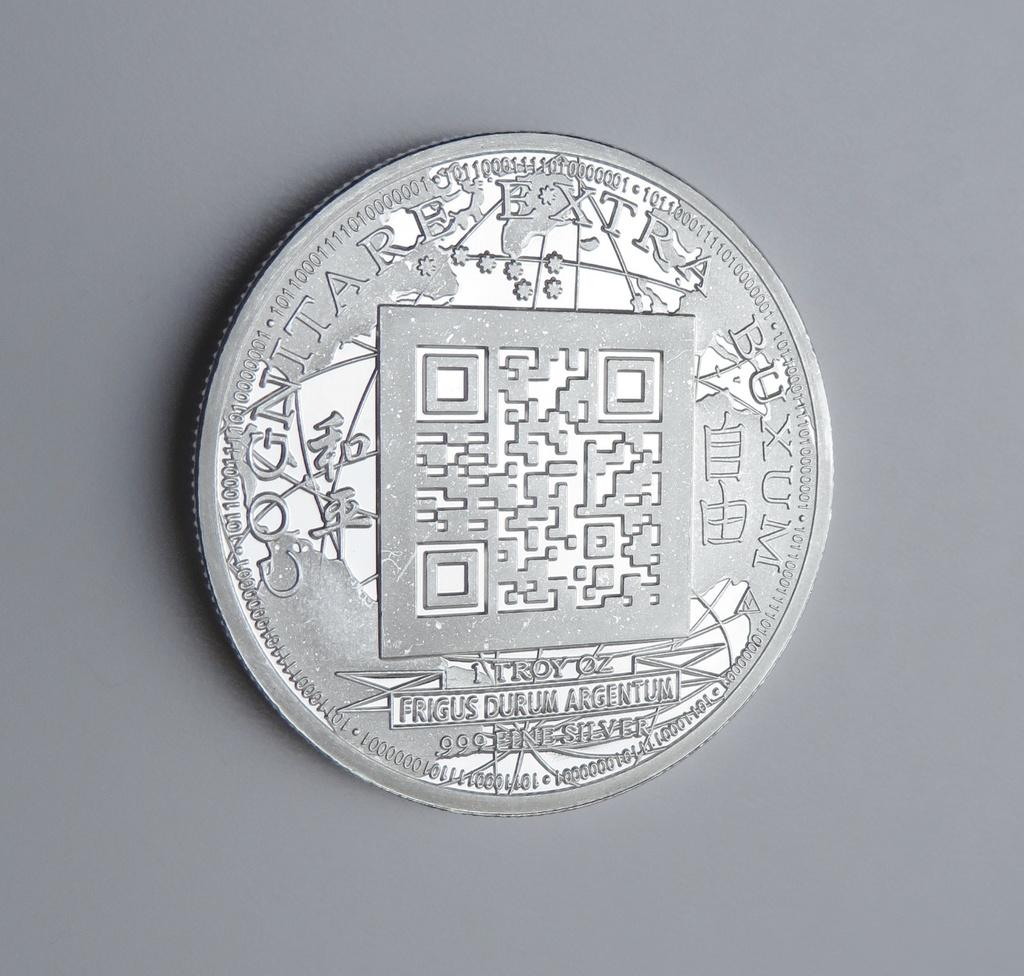Provide a one-sentence caption for the provided image. A 1 Troy oz coin made of .999 line silver lies on a grey background. 